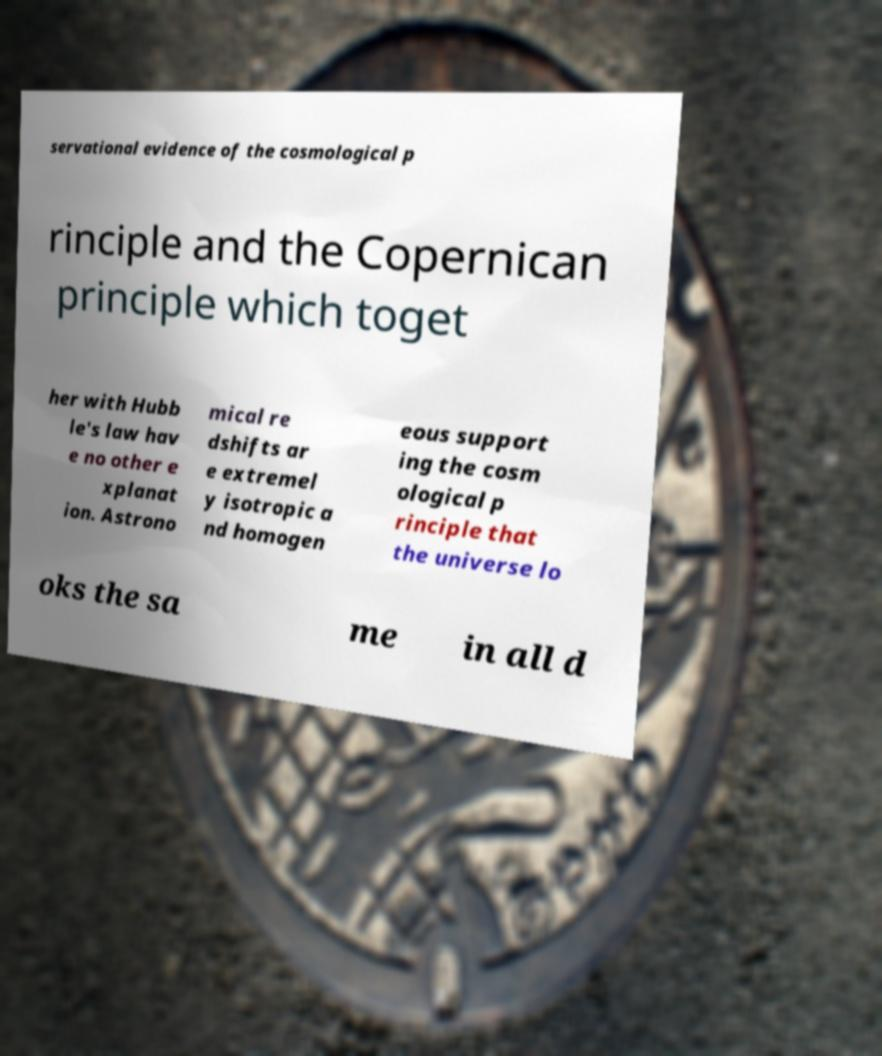For documentation purposes, I need the text within this image transcribed. Could you provide that? servational evidence of the cosmological p rinciple and the Copernican principle which toget her with Hubb le's law hav e no other e xplanat ion. Astrono mical re dshifts ar e extremel y isotropic a nd homogen eous support ing the cosm ological p rinciple that the universe lo oks the sa me in all d 